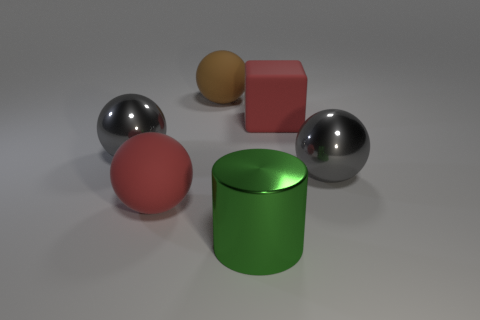Subtract all cyan balls. Subtract all cyan cubes. How many balls are left? 4 Add 3 small gray objects. How many objects exist? 9 Subtract all cylinders. How many objects are left? 5 Subtract all tiny yellow metal blocks. Subtract all big red matte blocks. How many objects are left? 5 Add 6 big red objects. How many big red objects are left? 8 Add 3 big red rubber cylinders. How many big red rubber cylinders exist? 3 Subtract 0 yellow cylinders. How many objects are left? 6 